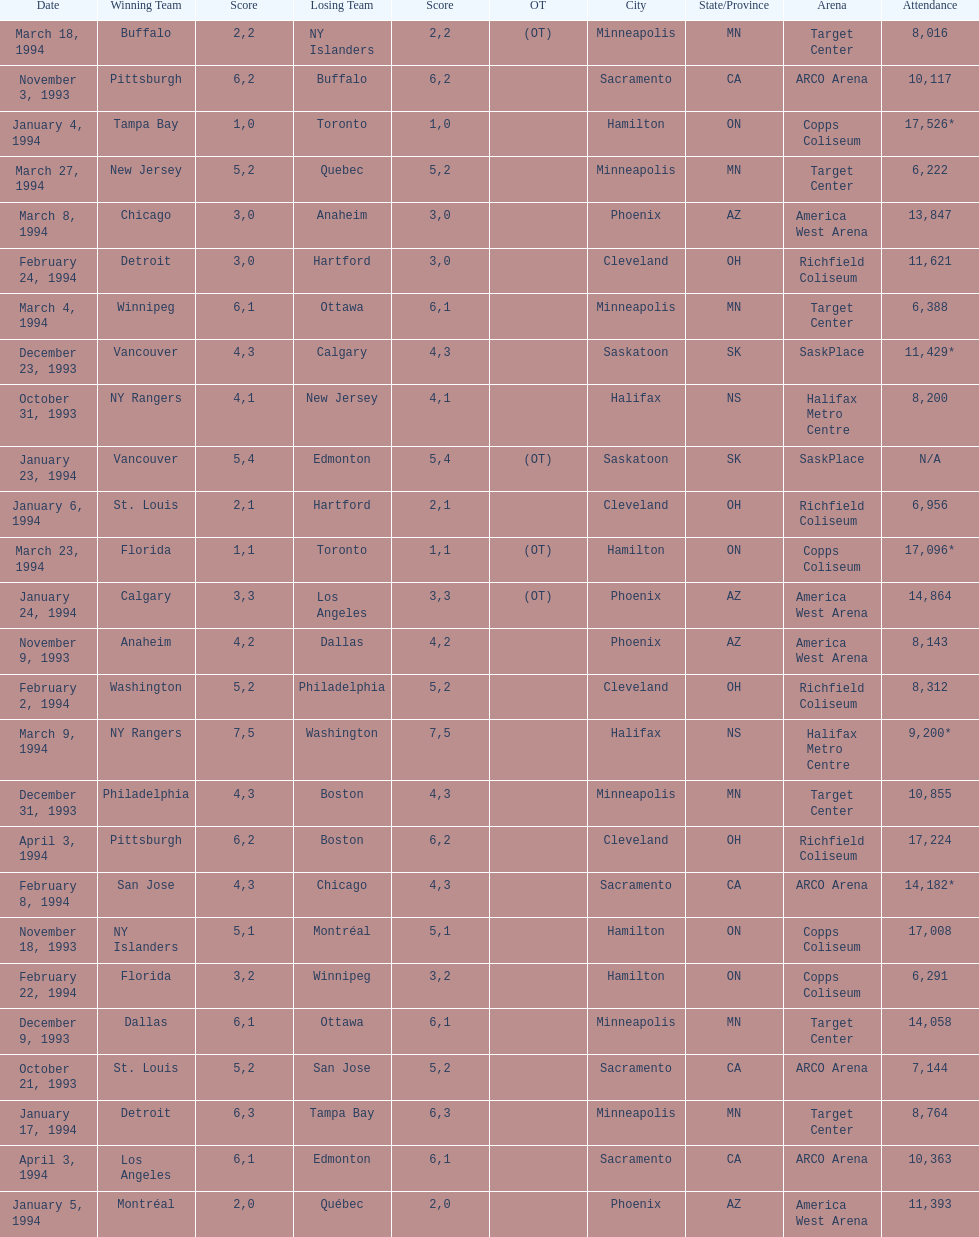Who won the game the day before the january 5, 1994 game? Tampa Bay. 